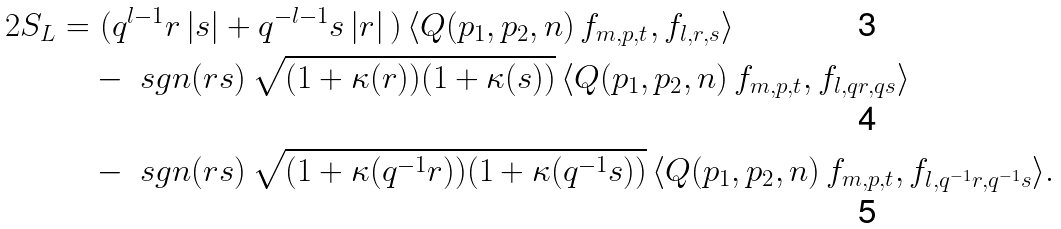Convert formula to latex. <formula><loc_0><loc_0><loc_500><loc_500>2 S _ { L } = & \ ( q ^ { l - 1 } r \, | s | + q ^ { - l - 1 } s \, | r | \, ) \, \langle Q ( p _ { 1 } , p _ { 2 } , n ) \, f _ { m , p , t } , f _ { l , r , s } \rangle \\ & - \ s g n ( r s ) \, \sqrt { ( 1 + \kappa ( r ) ) ( 1 + \kappa ( s ) ) } \, \langle Q ( p _ { 1 } , p _ { 2 } , n ) \, f _ { m , p , t } , f _ { l , q r , q s } \rangle \\ & - \ s g n ( r s ) \, \sqrt { ( 1 + \kappa ( q ^ { - 1 } r ) ) ( 1 + \kappa ( q ^ { - 1 } s ) ) } \, \langle Q ( p _ { 1 } , p _ { 2 } , n ) \, f _ { m , p , t } , f _ { l , q ^ { - 1 } r , q ^ { - 1 } s } \rangle .</formula> 